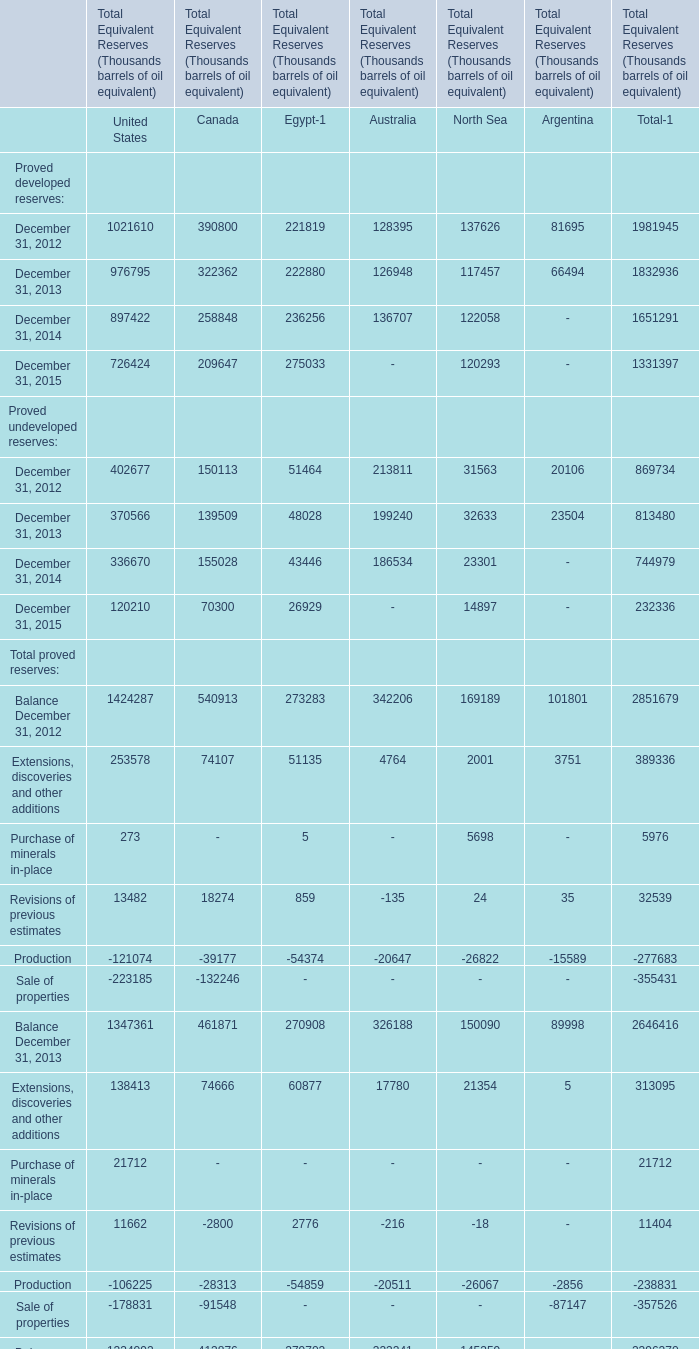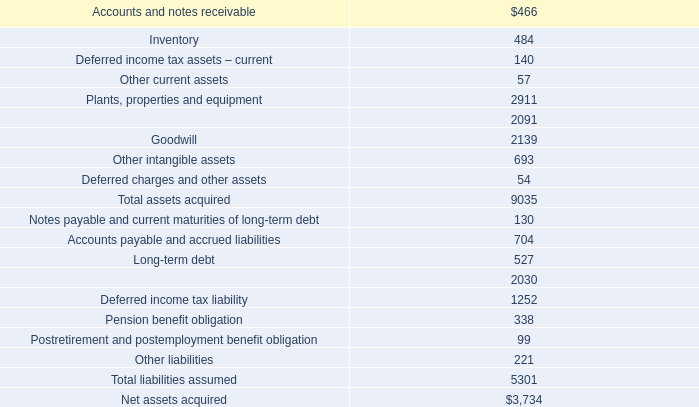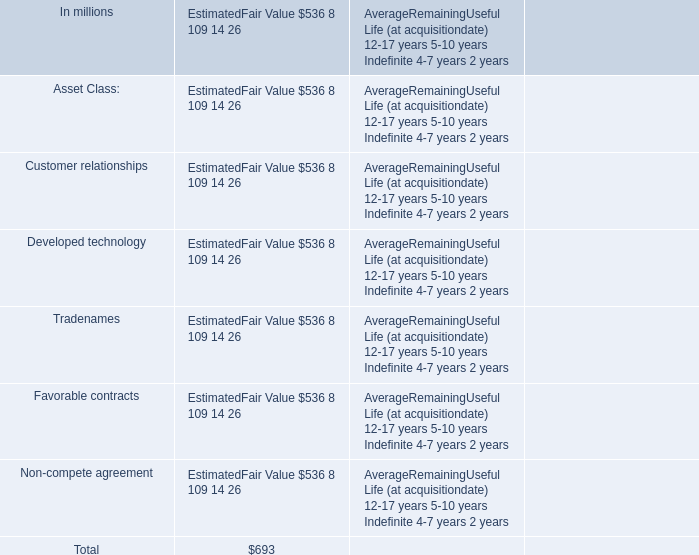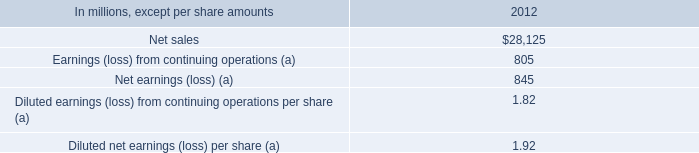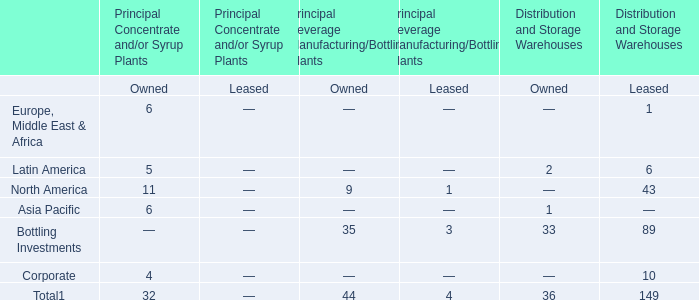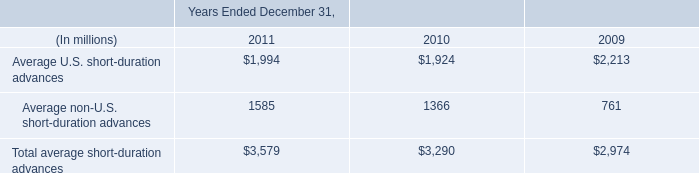what was the change in average other interest-earning assets in 2011 in millions 
Computations: (5.46 - 1.16)
Answer: 4.3. 